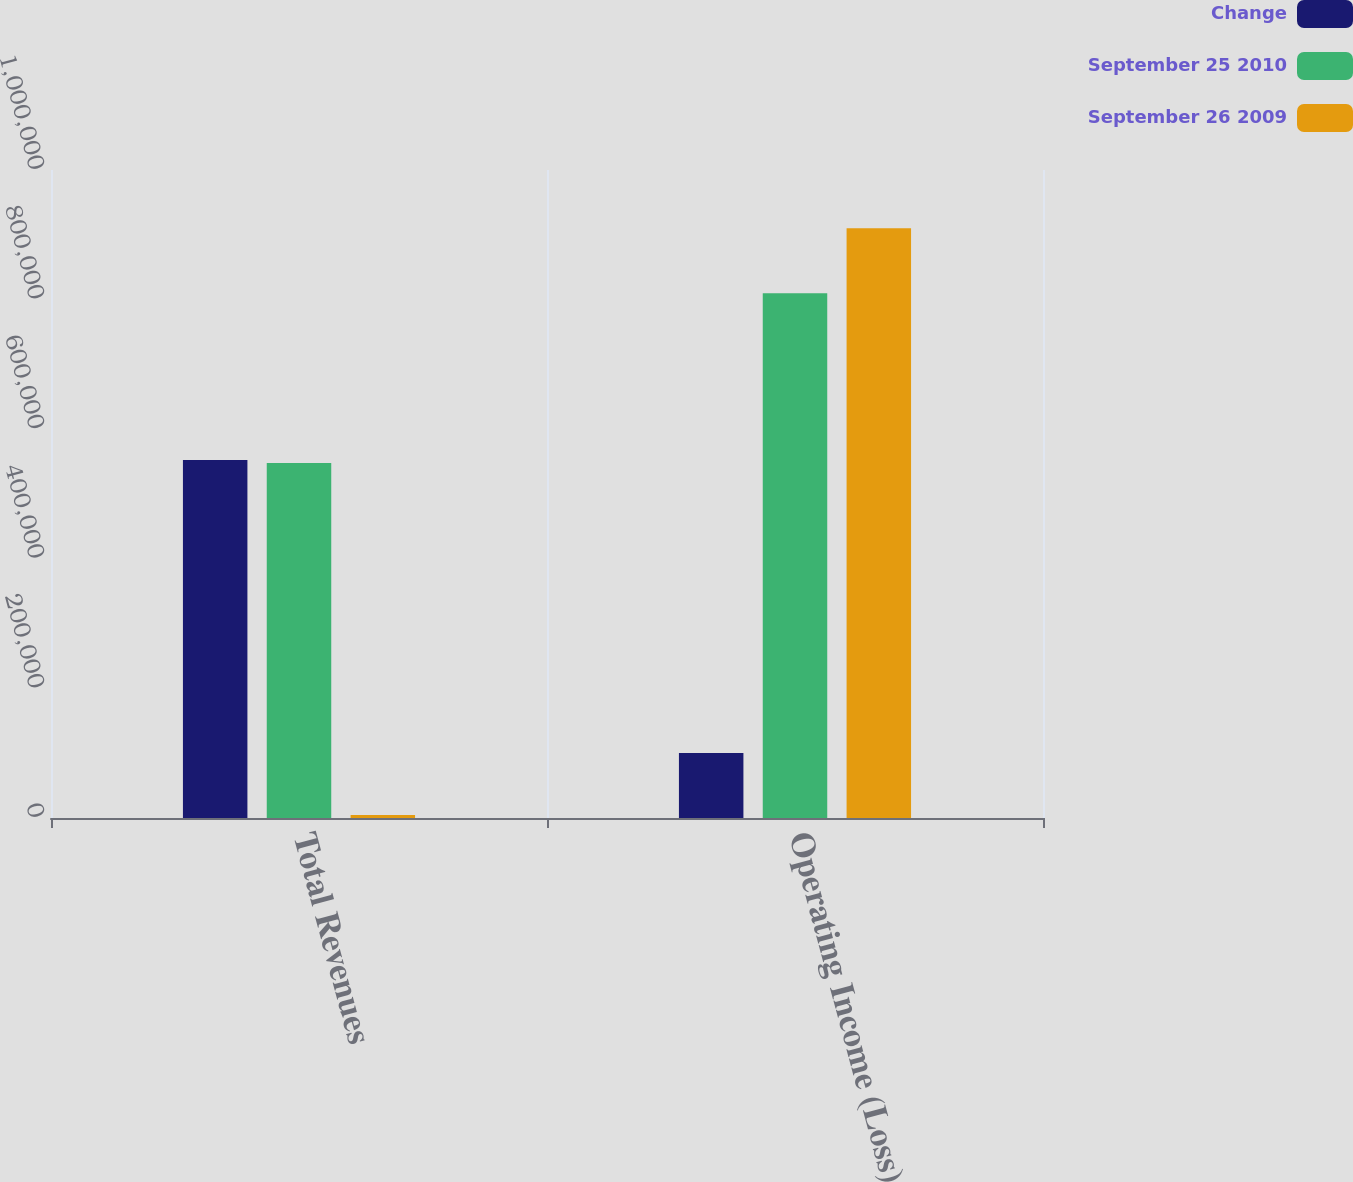Convert chart to OTSL. <chart><loc_0><loc_0><loc_500><loc_500><stacked_bar_chart><ecel><fcel>Total Revenues<fcel>Operating Income (Loss)<nl><fcel>Change<fcel>552501<fcel>100469<nl><fcel>September 25 2010<fcel>547892<fcel>809640<nl><fcel>September 26 2009<fcel>4609<fcel>910109<nl></chart> 